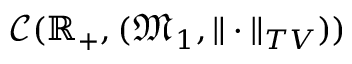Convert formula to latex. <formula><loc_0><loc_0><loc_500><loc_500>\mathcal { C } ( \mathbb { R } _ { + } , ( \mathfrak { M } _ { 1 } , \| \cdot \| _ { T V } ) )</formula> 